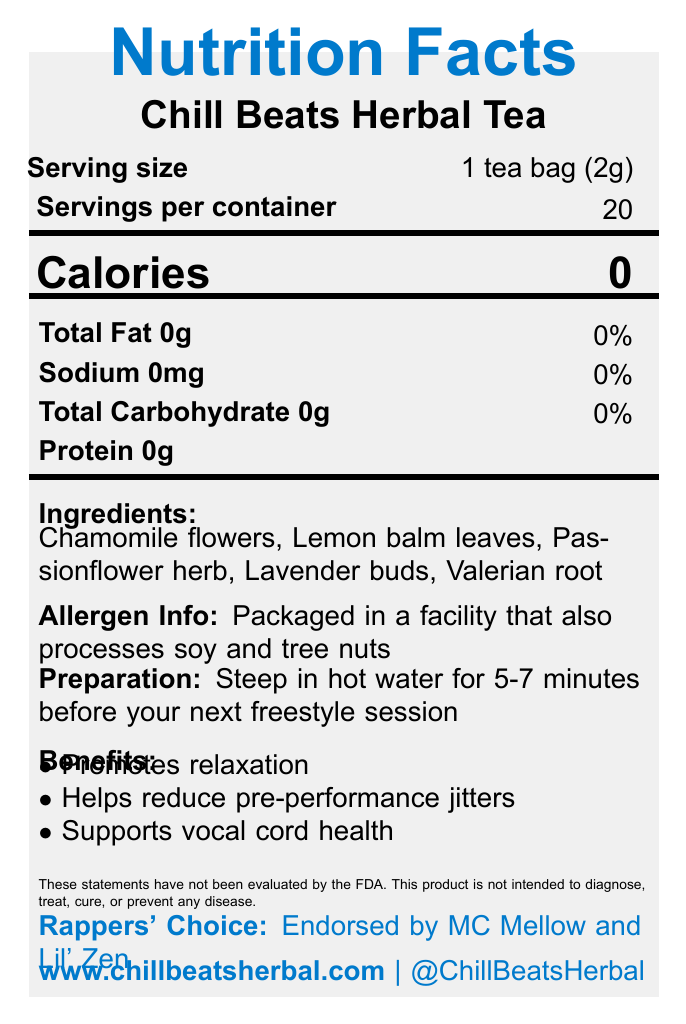What is the serving size of Chill Beats Herbal Tea? The document specifies that the serving size is "1 tea bag (2g)".
Answer: 1 tea bag (2g) How many calories are in one serving of Chill Beats Herbal Tea? The document states that each serving contains 0 calories.
Answer: 0 Name three ingredients in Chill Beats Herbal Tea. The ingredients listed in the document include Chamomile flowers, Lemon balm leaves, Passionflower herb, Lavender buds, and Valerian root.
Answer: Chamomile flowers, Lemon balm leaves, Passionflower herb What is the preparation method for Chill Beats Herbal Tea? The document instructs to steep the tea in hot water for 5-7 minutes before the next freestyle session.
Answer: Steep in hot water for 5-7 minutes before your next freestyle session How many servings are there per container of Chill Beats Herbal Tea? The document specifies that there are 20 servings per container.
Answer: 20 How much sodium is in each serving of Chill Beats Herbal Tea? A. 0mg B. 10mg C. 20mg D. 50mg The document states that there are 0mg of sodium per serving.
Answer: A. 0mg Who endorses Chill Beats Herbal Tea? A. DJ Hype B. MC Mellow and Lil' Zen C. Rapper X D. Beats Master The document mentions that the tea is endorsed by MC Mellow and Lil' Zen.
Answer: B. MC Mellow and Lil' Zen Is Chill Beats Herbal Tea caffeine-free? The document confirms that the tea contains 0mg of caffeine.
Answer: Yes Does Chill Beats Herbal Tea contain any fat? The document states that the total fat content is 0g.
Answer: No Summarize the main benefits of Chill Beats Herbal Tea. The document lists three main benefits of the tea: promoting relaxation, reducing pre-performance jitters, and supporting vocal cord health.
Answer: Promotes relaxation, helps reduce pre-performance jitters, supports vocal cord health What is the percentage of daily value for carbohydrates in Chill Beats Herbal Tea? The document does not provide information on the percentage daily value for carbohydrates.
Answer: Not enough information What is the main purpose of Chill Beats Herbal Tea according to the brand story? The brand story states that the tea is created to keep rappers chill before their performances.
Answer: Keep you chill before hitting the stage Is Chill Beats Herbal Tea organic? The document mentions that the product is organic.
Answer: Yes What specific allergens might be present due to the packaging facility? The document indicates that the product is packaged in a facility that also processes soy and tree nuts.
Answer: Soy and tree nuts What is the storage recommendation for Chill Beats Herbal Tea? The document advises storing the tea in a cool, dry place.
Answer: Store in a cool, dry place Summarize the entire document. The document provides various details including nutritional facts, ingredients, benefits, preparation method, endorsements, allergen information, storage recommendation, and brand story of Chill Beats Herbal Tea.
Answer: The document describes Chill Beats Herbal Tea, a caffeine-free herbal tea blend designed to promote relaxation, reduce pre-performance jitters, and support vocal cord health. It contains no calories, fat, sodium, carbohydrates, or protein. The ingredients are Chamomile flowers, Lemon balm leaves, Passionflower herb, Lavender buds, and Valerian root. The product comes with 20 servings per container and is endorsed by MC Mellow and Lil' Zen. It is packaged in a facility that also processes soy and tree nuts and should be stored in a cool, dry place. Preparation involves steeping in hot water for 5-7 minutes. 